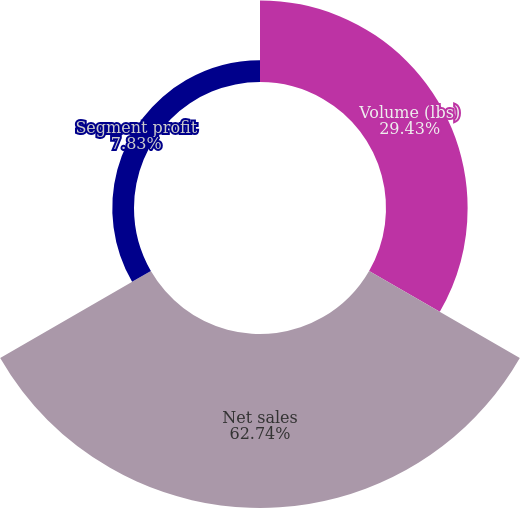Convert chart. <chart><loc_0><loc_0><loc_500><loc_500><pie_chart><fcel>Volume (lbs)<fcel>Net sales<fcel>Segment profit<nl><fcel>29.43%<fcel>62.74%<fcel>7.83%<nl></chart> 